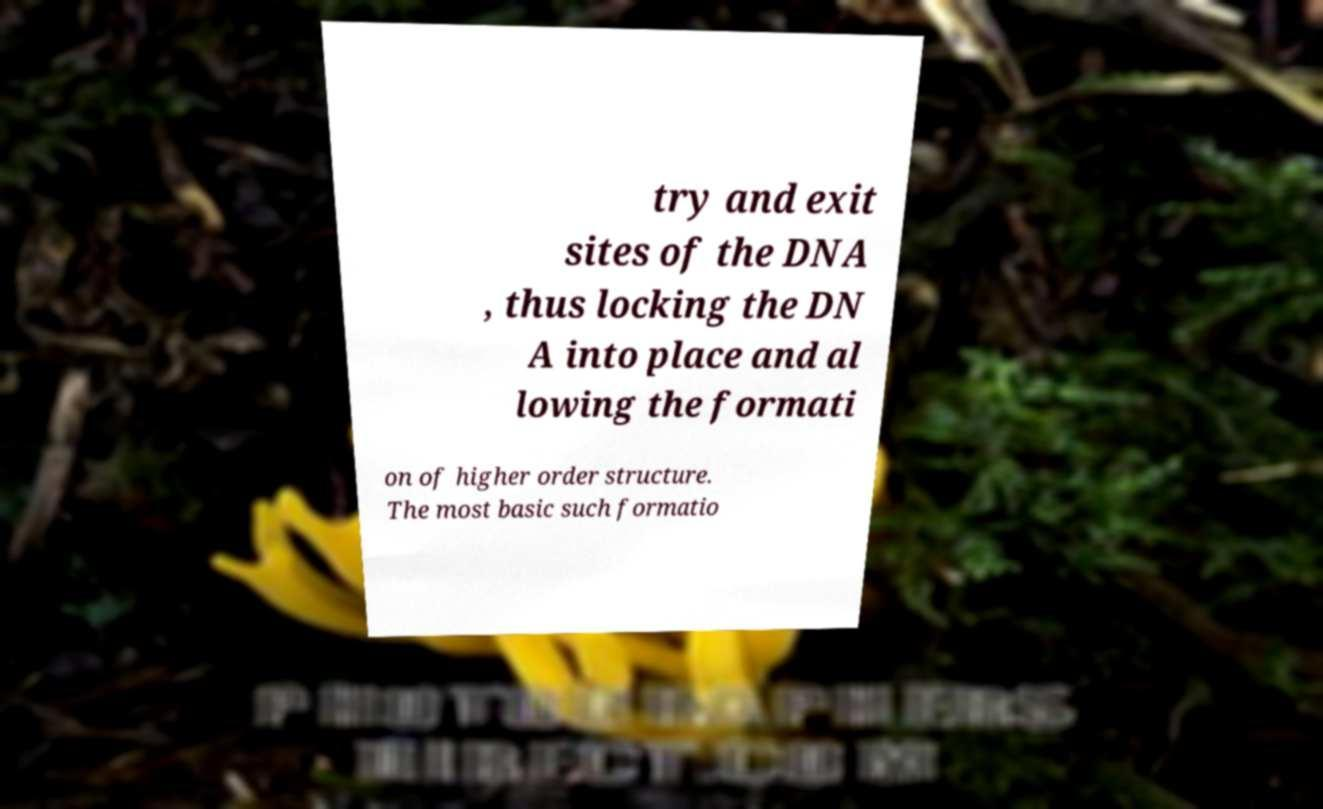Please read and relay the text visible in this image. What does it say? try and exit sites of the DNA , thus locking the DN A into place and al lowing the formati on of higher order structure. The most basic such formatio 